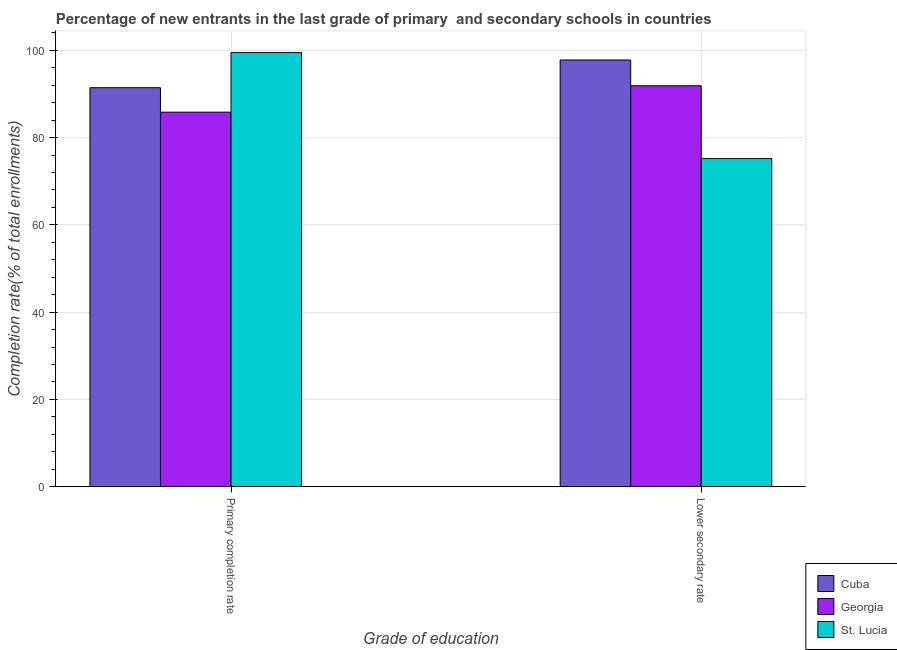How many groups of bars are there?
Provide a short and direct response. 2. Are the number of bars per tick equal to the number of legend labels?
Offer a very short reply. Yes. Are the number of bars on each tick of the X-axis equal?
Give a very brief answer. Yes. How many bars are there on the 2nd tick from the left?
Give a very brief answer. 3. How many bars are there on the 1st tick from the right?
Make the answer very short. 3. What is the label of the 2nd group of bars from the left?
Make the answer very short. Lower secondary rate. What is the completion rate in primary schools in Cuba?
Give a very brief answer. 91.42. Across all countries, what is the maximum completion rate in secondary schools?
Keep it short and to the point. 97.77. Across all countries, what is the minimum completion rate in primary schools?
Give a very brief answer. 85.81. In which country was the completion rate in secondary schools maximum?
Give a very brief answer. Cuba. In which country was the completion rate in primary schools minimum?
Keep it short and to the point. Georgia. What is the total completion rate in primary schools in the graph?
Provide a succinct answer. 276.71. What is the difference between the completion rate in secondary schools in Georgia and that in Cuba?
Offer a terse response. -5.91. What is the difference between the completion rate in secondary schools in Cuba and the completion rate in primary schools in Georgia?
Provide a succinct answer. 11.96. What is the average completion rate in primary schools per country?
Keep it short and to the point. 92.24. What is the difference between the completion rate in secondary schools and completion rate in primary schools in St. Lucia?
Offer a terse response. -24.27. What is the ratio of the completion rate in secondary schools in Georgia to that in St. Lucia?
Provide a succinct answer. 1.22. Is the completion rate in secondary schools in Cuba less than that in Georgia?
Ensure brevity in your answer.  No. What does the 2nd bar from the left in Lower secondary rate represents?
Your answer should be very brief. Georgia. What does the 1st bar from the right in Lower secondary rate represents?
Keep it short and to the point. St. Lucia. How many bars are there?
Your response must be concise. 6. What is the difference between two consecutive major ticks on the Y-axis?
Ensure brevity in your answer.  20. Where does the legend appear in the graph?
Give a very brief answer. Bottom right. How many legend labels are there?
Make the answer very short. 3. What is the title of the graph?
Offer a terse response. Percentage of new entrants in the last grade of primary  and secondary schools in countries. Does "Virgin Islands" appear as one of the legend labels in the graph?
Your answer should be very brief. No. What is the label or title of the X-axis?
Make the answer very short. Grade of education. What is the label or title of the Y-axis?
Offer a terse response. Completion rate(% of total enrollments). What is the Completion rate(% of total enrollments) in Cuba in Primary completion rate?
Keep it short and to the point. 91.42. What is the Completion rate(% of total enrollments) of Georgia in Primary completion rate?
Provide a succinct answer. 85.81. What is the Completion rate(% of total enrollments) in St. Lucia in Primary completion rate?
Provide a short and direct response. 99.48. What is the Completion rate(% of total enrollments) in Cuba in Lower secondary rate?
Ensure brevity in your answer.  97.77. What is the Completion rate(% of total enrollments) in Georgia in Lower secondary rate?
Your response must be concise. 91.86. What is the Completion rate(% of total enrollments) in St. Lucia in Lower secondary rate?
Your response must be concise. 75.21. Across all Grade of education, what is the maximum Completion rate(% of total enrollments) of Cuba?
Provide a short and direct response. 97.77. Across all Grade of education, what is the maximum Completion rate(% of total enrollments) of Georgia?
Your answer should be very brief. 91.86. Across all Grade of education, what is the maximum Completion rate(% of total enrollments) in St. Lucia?
Your response must be concise. 99.48. Across all Grade of education, what is the minimum Completion rate(% of total enrollments) in Cuba?
Provide a short and direct response. 91.42. Across all Grade of education, what is the minimum Completion rate(% of total enrollments) of Georgia?
Keep it short and to the point. 85.81. Across all Grade of education, what is the minimum Completion rate(% of total enrollments) of St. Lucia?
Your answer should be compact. 75.21. What is the total Completion rate(% of total enrollments) in Cuba in the graph?
Your response must be concise. 189.19. What is the total Completion rate(% of total enrollments) of Georgia in the graph?
Offer a very short reply. 177.68. What is the total Completion rate(% of total enrollments) of St. Lucia in the graph?
Your answer should be compact. 174.69. What is the difference between the Completion rate(% of total enrollments) of Cuba in Primary completion rate and that in Lower secondary rate?
Your answer should be compact. -6.35. What is the difference between the Completion rate(% of total enrollments) in Georgia in Primary completion rate and that in Lower secondary rate?
Your answer should be very brief. -6.05. What is the difference between the Completion rate(% of total enrollments) in St. Lucia in Primary completion rate and that in Lower secondary rate?
Keep it short and to the point. 24.27. What is the difference between the Completion rate(% of total enrollments) in Cuba in Primary completion rate and the Completion rate(% of total enrollments) in Georgia in Lower secondary rate?
Your response must be concise. -0.44. What is the difference between the Completion rate(% of total enrollments) of Cuba in Primary completion rate and the Completion rate(% of total enrollments) of St. Lucia in Lower secondary rate?
Your response must be concise. 16.22. What is the difference between the Completion rate(% of total enrollments) of Georgia in Primary completion rate and the Completion rate(% of total enrollments) of St. Lucia in Lower secondary rate?
Your answer should be compact. 10.61. What is the average Completion rate(% of total enrollments) in Cuba per Grade of education?
Offer a very short reply. 94.6. What is the average Completion rate(% of total enrollments) in Georgia per Grade of education?
Your answer should be very brief. 88.84. What is the average Completion rate(% of total enrollments) in St. Lucia per Grade of education?
Provide a succinct answer. 87.34. What is the difference between the Completion rate(% of total enrollments) of Cuba and Completion rate(% of total enrollments) of Georgia in Primary completion rate?
Offer a terse response. 5.61. What is the difference between the Completion rate(% of total enrollments) of Cuba and Completion rate(% of total enrollments) of St. Lucia in Primary completion rate?
Provide a succinct answer. -8.06. What is the difference between the Completion rate(% of total enrollments) of Georgia and Completion rate(% of total enrollments) of St. Lucia in Primary completion rate?
Your answer should be compact. -13.67. What is the difference between the Completion rate(% of total enrollments) of Cuba and Completion rate(% of total enrollments) of Georgia in Lower secondary rate?
Offer a very short reply. 5.91. What is the difference between the Completion rate(% of total enrollments) in Cuba and Completion rate(% of total enrollments) in St. Lucia in Lower secondary rate?
Ensure brevity in your answer.  22.56. What is the difference between the Completion rate(% of total enrollments) in Georgia and Completion rate(% of total enrollments) in St. Lucia in Lower secondary rate?
Ensure brevity in your answer.  16.66. What is the ratio of the Completion rate(% of total enrollments) of Cuba in Primary completion rate to that in Lower secondary rate?
Make the answer very short. 0.94. What is the ratio of the Completion rate(% of total enrollments) in Georgia in Primary completion rate to that in Lower secondary rate?
Your answer should be very brief. 0.93. What is the ratio of the Completion rate(% of total enrollments) in St. Lucia in Primary completion rate to that in Lower secondary rate?
Give a very brief answer. 1.32. What is the difference between the highest and the second highest Completion rate(% of total enrollments) of Cuba?
Give a very brief answer. 6.35. What is the difference between the highest and the second highest Completion rate(% of total enrollments) of Georgia?
Provide a short and direct response. 6.05. What is the difference between the highest and the second highest Completion rate(% of total enrollments) of St. Lucia?
Your answer should be very brief. 24.27. What is the difference between the highest and the lowest Completion rate(% of total enrollments) in Cuba?
Your response must be concise. 6.35. What is the difference between the highest and the lowest Completion rate(% of total enrollments) in Georgia?
Your answer should be compact. 6.05. What is the difference between the highest and the lowest Completion rate(% of total enrollments) in St. Lucia?
Your response must be concise. 24.27. 